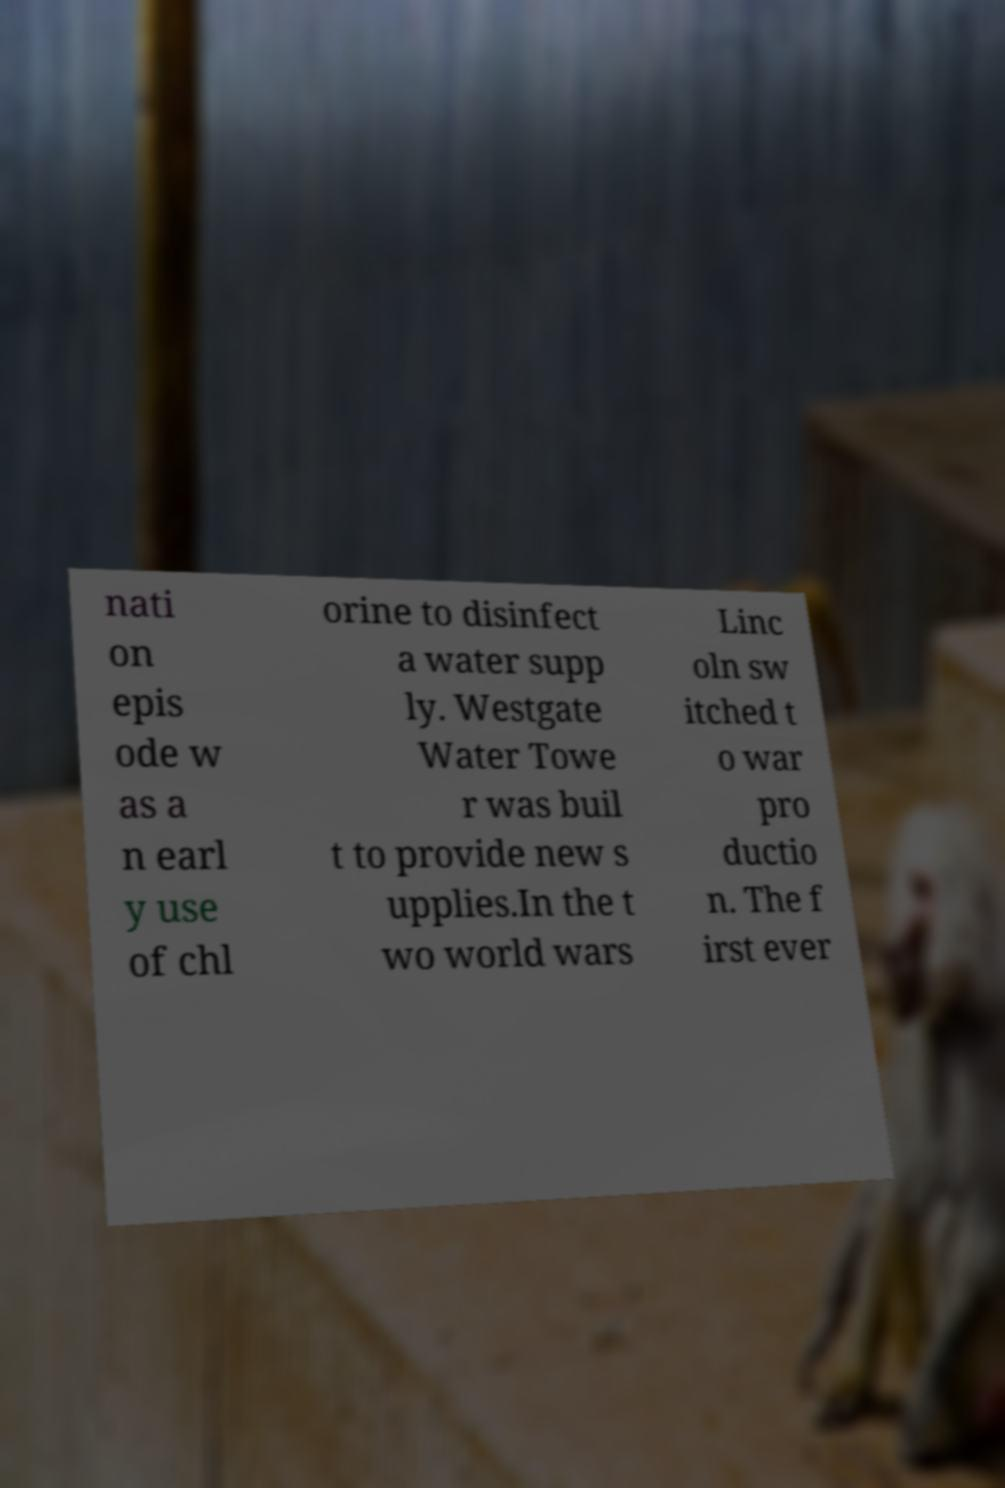Could you extract and type out the text from this image? nati on epis ode w as a n earl y use of chl orine to disinfect a water supp ly. Westgate Water Towe r was buil t to provide new s upplies.In the t wo world wars Linc oln sw itched t o war pro ductio n. The f irst ever 